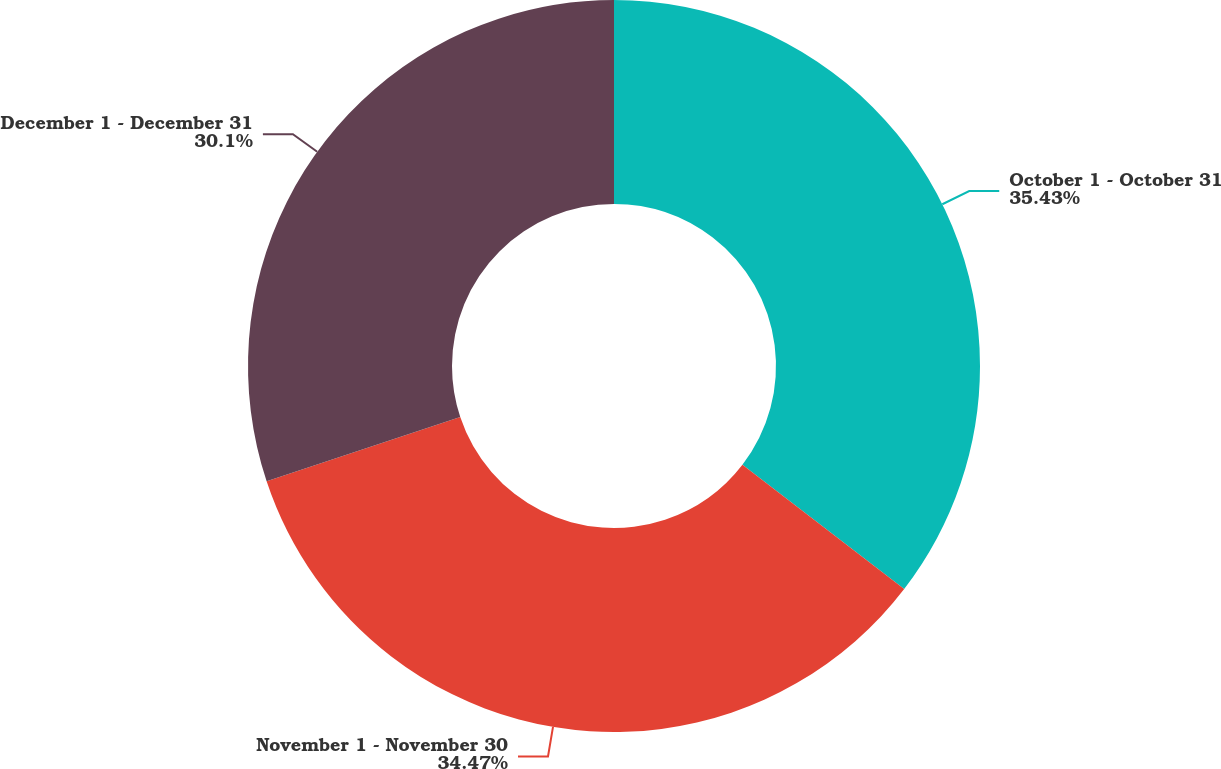<chart> <loc_0><loc_0><loc_500><loc_500><pie_chart><fcel>October 1 - October 31<fcel>November 1 - November 30<fcel>December 1 - December 31<nl><fcel>35.43%<fcel>34.47%<fcel>30.1%<nl></chart> 